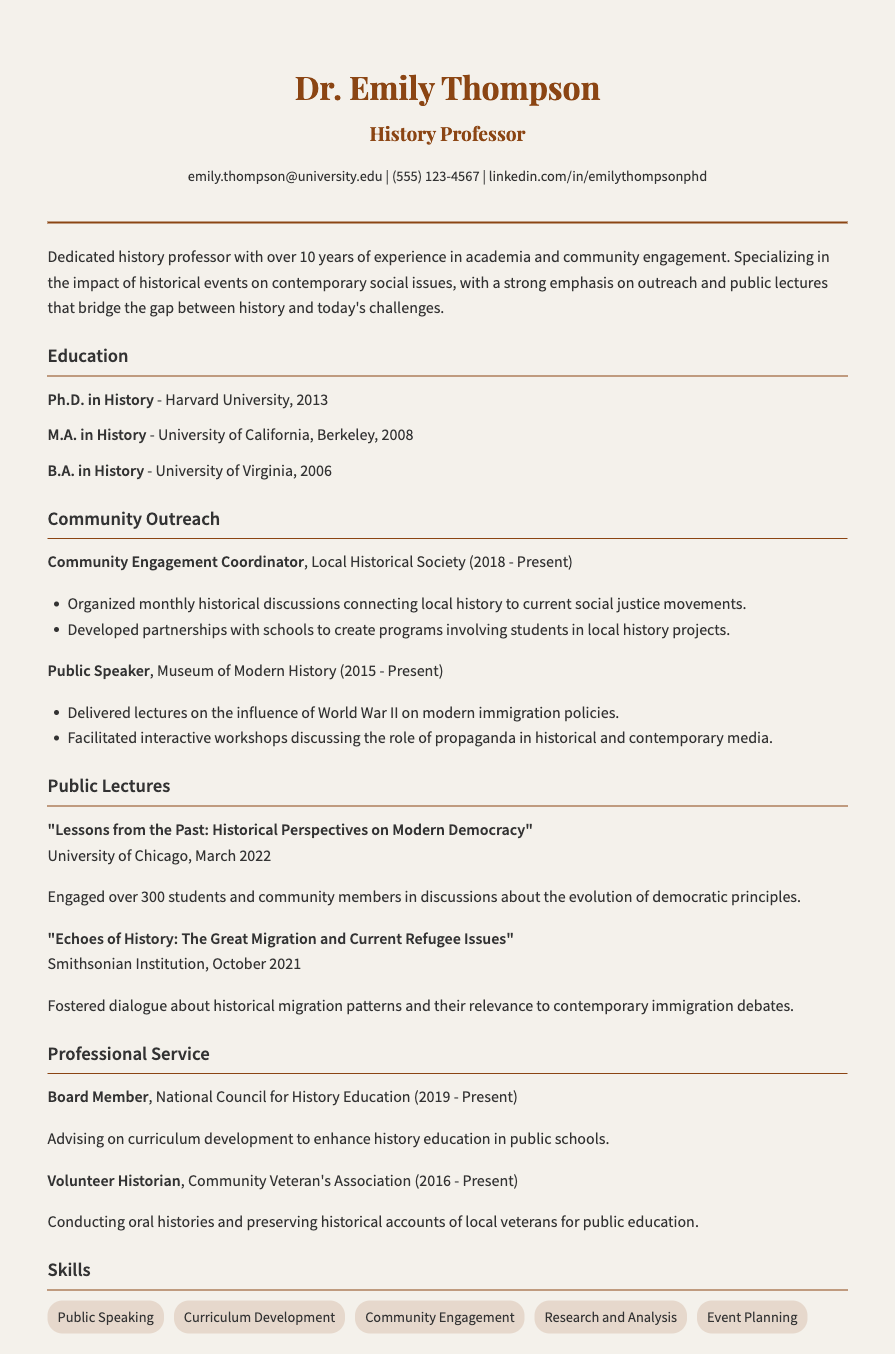What is Dr. Emily Thompson's email address? The email address is provided in the contact information section of the document.
Answer: emily.thompson@university.edu What year did Dr. Emily Thompson earn her Ph.D.? The year is listed under the education section, specifically for her Ph.D. in History.
Answer: 2013 Which institution did Dr. Thompson deliver a lecture at in March 2022? The location of the lecture is mentioned along with the title of the lecture.
Answer: University of Chicago What role does Dr. Thompson serve at the Local Historical Society? This information relates to her position mentioned in the community outreach section.
Answer: Community Engagement Coordinator How many years has Dr. Thompson been involved with the National Council for History Education? This is deduced from the start year of her position and the present time stated in the document.
Answer: 4 years What is the main focus of Dr. Thompson's public lectures? The focal points of her lectures can be inferred from the titles and descriptions provided.
Answer: Connecting historical topics to contemporary issues What type of community programs has Dr. Thompson helped develop? This involves reasoning from her community outreach activities described in the document.
Answer: Programs involving students in local history projects What skill related to event management is included in Dr. Thompson's skills section? The skills section lists various competencies, including those related to organizing events.
Answer: Event Planning Which committee does Dr. Thompson serve on that influences history education in public schools? This indicates her involvement in professional service, as specified in the document.
Answer: National Council for History Education 